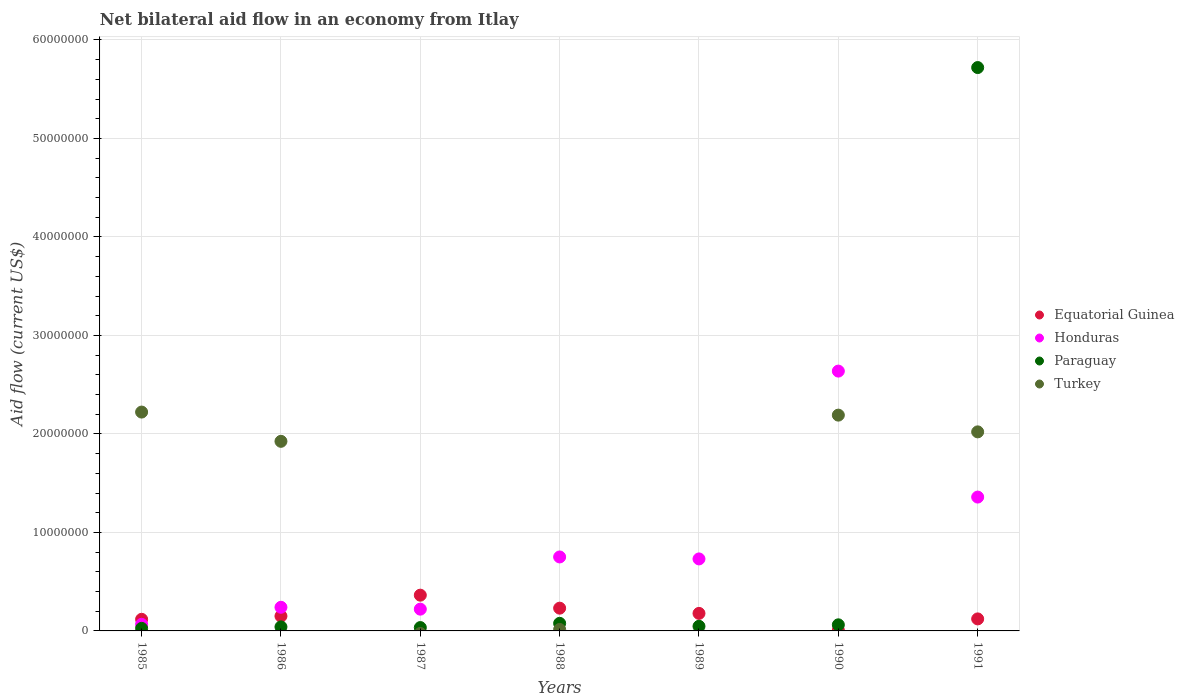How many different coloured dotlines are there?
Provide a succinct answer. 4. Across all years, what is the maximum net bilateral aid flow in Turkey?
Provide a succinct answer. 2.22e+07. Across all years, what is the minimum net bilateral aid flow in Turkey?
Your answer should be very brief. 0. What is the total net bilateral aid flow in Turkey in the graph?
Keep it short and to the point. 8.37e+07. What is the difference between the net bilateral aid flow in Honduras in 1988 and the net bilateral aid flow in Equatorial Guinea in 1989?
Your answer should be very brief. 5.73e+06. What is the average net bilateral aid flow in Honduras per year?
Offer a terse response. 8.58e+06. In the year 1986, what is the difference between the net bilateral aid flow in Turkey and net bilateral aid flow in Paraguay?
Your answer should be very brief. 1.88e+07. What is the ratio of the net bilateral aid flow in Equatorial Guinea in 1986 to that in 1989?
Provide a succinct answer. 0.84. What is the difference between the highest and the lowest net bilateral aid flow in Turkey?
Provide a succinct answer. 2.22e+07. In how many years, is the net bilateral aid flow in Equatorial Guinea greater than the average net bilateral aid flow in Equatorial Guinea taken over all years?
Offer a very short reply. 3. Is it the case that in every year, the sum of the net bilateral aid flow in Paraguay and net bilateral aid flow in Equatorial Guinea  is greater than the sum of net bilateral aid flow in Honduras and net bilateral aid flow in Turkey?
Offer a very short reply. Yes. Is the net bilateral aid flow in Paraguay strictly greater than the net bilateral aid flow in Turkey over the years?
Ensure brevity in your answer.  No. How many years are there in the graph?
Your answer should be very brief. 7. Are the values on the major ticks of Y-axis written in scientific E-notation?
Keep it short and to the point. No. Does the graph contain grids?
Your response must be concise. Yes. Where does the legend appear in the graph?
Make the answer very short. Center right. How are the legend labels stacked?
Offer a very short reply. Vertical. What is the title of the graph?
Your response must be concise. Net bilateral aid flow in an economy from Itlay. What is the Aid flow (current US$) in Equatorial Guinea in 1985?
Your answer should be compact. 1.18e+06. What is the Aid flow (current US$) of Honduras in 1985?
Provide a succinct answer. 6.70e+05. What is the Aid flow (current US$) of Paraguay in 1985?
Your response must be concise. 2.60e+05. What is the Aid flow (current US$) in Turkey in 1985?
Your answer should be very brief. 2.22e+07. What is the Aid flow (current US$) of Equatorial Guinea in 1986?
Give a very brief answer. 1.50e+06. What is the Aid flow (current US$) of Honduras in 1986?
Offer a very short reply. 2.40e+06. What is the Aid flow (current US$) of Turkey in 1986?
Offer a terse response. 1.92e+07. What is the Aid flow (current US$) in Equatorial Guinea in 1987?
Offer a very short reply. 3.63e+06. What is the Aid flow (current US$) of Honduras in 1987?
Keep it short and to the point. 2.21e+06. What is the Aid flow (current US$) of Paraguay in 1987?
Your answer should be compact. 3.40e+05. What is the Aid flow (current US$) of Equatorial Guinea in 1988?
Your answer should be compact. 2.31e+06. What is the Aid flow (current US$) of Honduras in 1988?
Your answer should be very brief. 7.51e+06. What is the Aid flow (current US$) of Paraguay in 1988?
Make the answer very short. 7.70e+05. What is the Aid flow (current US$) in Equatorial Guinea in 1989?
Provide a short and direct response. 1.78e+06. What is the Aid flow (current US$) in Honduras in 1989?
Offer a very short reply. 7.31e+06. What is the Aid flow (current US$) in Paraguay in 1989?
Keep it short and to the point. 4.70e+05. What is the Aid flow (current US$) in Equatorial Guinea in 1990?
Make the answer very short. 7.00e+04. What is the Aid flow (current US$) of Honduras in 1990?
Your answer should be compact. 2.64e+07. What is the Aid flow (current US$) of Paraguay in 1990?
Your answer should be very brief. 6.20e+05. What is the Aid flow (current US$) in Turkey in 1990?
Give a very brief answer. 2.19e+07. What is the Aid flow (current US$) in Equatorial Guinea in 1991?
Your response must be concise. 1.22e+06. What is the Aid flow (current US$) of Honduras in 1991?
Make the answer very short. 1.36e+07. What is the Aid flow (current US$) in Paraguay in 1991?
Offer a terse response. 5.72e+07. What is the Aid flow (current US$) of Turkey in 1991?
Ensure brevity in your answer.  2.02e+07. Across all years, what is the maximum Aid flow (current US$) of Equatorial Guinea?
Give a very brief answer. 3.63e+06. Across all years, what is the maximum Aid flow (current US$) in Honduras?
Keep it short and to the point. 2.64e+07. Across all years, what is the maximum Aid flow (current US$) of Paraguay?
Make the answer very short. 5.72e+07. Across all years, what is the maximum Aid flow (current US$) in Turkey?
Your response must be concise. 2.22e+07. Across all years, what is the minimum Aid flow (current US$) of Equatorial Guinea?
Provide a short and direct response. 7.00e+04. Across all years, what is the minimum Aid flow (current US$) of Honduras?
Keep it short and to the point. 6.70e+05. What is the total Aid flow (current US$) in Equatorial Guinea in the graph?
Your answer should be very brief. 1.17e+07. What is the total Aid flow (current US$) in Honduras in the graph?
Your response must be concise. 6.01e+07. What is the total Aid flow (current US$) of Paraguay in the graph?
Ensure brevity in your answer.  6.01e+07. What is the total Aid flow (current US$) in Turkey in the graph?
Your answer should be compact. 8.37e+07. What is the difference between the Aid flow (current US$) in Equatorial Guinea in 1985 and that in 1986?
Provide a succinct answer. -3.20e+05. What is the difference between the Aid flow (current US$) of Honduras in 1985 and that in 1986?
Your response must be concise. -1.73e+06. What is the difference between the Aid flow (current US$) of Turkey in 1985 and that in 1986?
Offer a very short reply. 2.97e+06. What is the difference between the Aid flow (current US$) in Equatorial Guinea in 1985 and that in 1987?
Your response must be concise. -2.45e+06. What is the difference between the Aid flow (current US$) in Honduras in 1985 and that in 1987?
Your response must be concise. -1.54e+06. What is the difference between the Aid flow (current US$) in Paraguay in 1985 and that in 1987?
Your answer should be compact. -8.00e+04. What is the difference between the Aid flow (current US$) in Equatorial Guinea in 1985 and that in 1988?
Give a very brief answer. -1.13e+06. What is the difference between the Aid flow (current US$) in Honduras in 1985 and that in 1988?
Ensure brevity in your answer.  -6.84e+06. What is the difference between the Aid flow (current US$) in Paraguay in 1985 and that in 1988?
Ensure brevity in your answer.  -5.10e+05. What is the difference between the Aid flow (current US$) in Turkey in 1985 and that in 1988?
Give a very brief answer. 2.21e+07. What is the difference between the Aid flow (current US$) of Equatorial Guinea in 1985 and that in 1989?
Ensure brevity in your answer.  -6.00e+05. What is the difference between the Aid flow (current US$) in Honduras in 1985 and that in 1989?
Provide a short and direct response. -6.64e+06. What is the difference between the Aid flow (current US$) of Paraguay in 1985 and that in 1989?
Provide a short and direct response. -2.10e+05. What is the difference between the Aid flow (current US$) in Equatorial Guinea in 1985 and that in 1990?
Offer a terse response. 1.11e+06. What is the difference between the Aid flow (current US$) of Honduras in 1985 and that in 1990?
Offer a terse response. -2.57e+07. What is the difference between the Aid flow (current US$) in Paraguay in 1985 and that in 1990?
Keep it short and to the point. -3.60e+05. What is the difference between the Aid flow (current US$) of Turkey in 1985 and that in 1990?
Offer a terse response. 3.10e+05. What is the difference between the Aid flow (current US$) of Honduras in 1985 and that in 1991?
Ensure brevity in your answer.  -1.29e+07. What is the difference between the Aid flow (current US$) of Paraguay in 1985 and that in 1991?
Your answer should be compact. -5.69e+07. What is the difference between the Aid flow (current US$) in Turkey in 1985 and that in 1991?
Keep it short and to the point. 2.01e+06. What is the difference between the Aid flow (current US$) in Equatorial Guinea in 1986 and that in 1987?
Your answer should be compact. -2.13e+06. What is the difference between the Aid flow (current US$) of Honduras in 1986 and that in 1987?
Provide a short and direct response. 1.90e+05. What is the difference between the Aid flow (current US$) in Paraguay in 1986 and that in 1987?
Make the answer very short. 7.00e+04. What is the difference between the Aid flow (current US$) of Equatorial Guinea in 1986 and that in 1988?
Your answer should be very brief. -8.10e+05. What is the difference between the Aid flow (current US$) in Honduras in 1986 and that in 1988?
Provide a short and direct response. -5.11e+06. What is the difference between the Aid flow (current US$) in Paraguay in 1986 and that in 1988?
Provide a succinct answer. -3.60e+05. What is the difference between the Aid flow (current US$) in Turkey in 1986 and that in 1988?
Your answer should be compact. 1.91e+07. What is the difference between the Aid flow (current US$) of Equatorial Guinea in 1986 and that in 1989?
Your answer should be very brief. -2.80e+05. What is the difference between the Aid flow (current US$) in Honduras in 1986 and that in 1989?
Ensure brevity in your answer.  -4.91e+06. What is the difference between the Aid flow (current US$) in Equatorial Guinea in 1986 and that in 1990?
Give a very brief answer. 1.43e+06. What is the difference between the Aid flow (current US$) of Honduras in 1986 and that in 1990?
Provide a succinct answer. -2.40e+07. What is the difference between the Aid flow (current US$) in Paraguay in 1986 and that in 1990?
Ensure brevity in your answer.  -2.10e+05. What is the difference between the Aid flow (current US$) of Turkey in 1986 and that in 1990?
Ensure brevity in your answer.  -2.66e+06. What is the difference between the Aid flow (current US$) of Equatorial Guinea in 1986 and that in 1991?
Your answer should be very brief. 2.80e+05. What is the difference between the Aid flow (current US$) in Honduras in 1986 and that in 1991?
Provide a short and direct response. -1.12e+07. What is the difference between the Aid flow (current US$) in Paraguay in 1986 and that in 1991?
Provide a short and direct response. -5.68e+07. What is the difference between the Aid flow (current US$) in Turkey in 1986 and that in 1991?
Your answer should be compact. -9.60e+05. What is the difference between the Aid flow (current US$) in Equatorial Guinea in 1987 and that in 1988?
Keep it short and to the point. 1.32e+06. What is the difference between the Aid flow (current US$) in Honduras in 1987 and that in 1988?
Keep it short and to the point. -5.30e+06. What is the difference between the Aid flow (current US$) in Paraguay in 1987 and that in 1988?
Make the answer very short. -4.30e+05. What is the difference between the Aid flow (current US$) in Equatorial Guinea in 1987 and that in 1989?
Your response must be concise. 1.85e+06. What is the difference between the Aid flow (current US$) in Honduras in 1987 and that in 1989?
Make the answer very short. -5.10e+06. What is the difference between the Aid flow (current US$) in Paraguay in 1987 and that in 1989?
Provide a short and direct response. -1.30e+05. What is the difference between the Aid flow (current US$) in Equatorial Guinea in 1987 and that in 1990?
Keep it short and to the point. 3.56e+06. What is the difference between the Aid flow (current US$) in Honduras in 1987 and that in 1990?
Offer a terse response. -2.42e+07. What is the difference between the Aid flow (current US$) of Paraguay in 1987 and that in 1990?
Provide a succinct answer. -2.80e+05. What is the difference between the Aid flow (current US$) of Equatorial Guinea in 1987 and that in 1991?
Give a very brief answer. 2.41e+06. What is the difference between the Aid flow (current US$) of Honduras in 1987 and that in 1991?
Provide a succinct answer. -1.14e+07. What is the difference between the Aid flow (current US$) of Paraguay in 1987 and that in 1991?
Ensure brevity in your answer.  -5.69e+07. What is the difference between the Aid flow (current US$) in Equatorial Guinea in 1988 and that in 1989?
Your response must be concise. 5.30e+05. What is the difference between the Aid flow (current US$) in Paraguay in 1988 and that in 1989?
Your response must be concise. 3.00e+05. What is the difference between the Aid flow (current US$) in Equatorial Guinea in 1988 and that in 1990?
Provide a short and direct response. 2.24e+06. What is the difference between the Aid flow (current US$) of Honduras in 1988 and that in 1990?
Provide a short and direct response. -1.89e+07. What is the difference between the Aid flow (current US$) of Paraguay in 1988 and that in 1990?
Your answer should be compact. 1.50e+05. What is the difference between the Aid flow (current US$) in Turkey in 1988 and that in 1990?
Your answer should be compact. -2.18e+07. What is the difference between the Aid flow (current US$) of Equatorial Guinea in 1988 and that in 1991?
Provide a succinct answer. 1.09e+06. What is the difference between the Aid flow (current US$) of Honduras in 1988 and that in 1991?
Your response must be concise. -6.08e+06. What is the difference between the Aid flow (current US$) in Paraguay in 1988 and that in 1991?
Your answer should be compact. -5.64e+07. What is the difference between the Aid flow (current US$) in Turkey in 1988 and that in 1991?
Your answer should be compact. -2.01e+07. What is the difference between the Aid flow (current US$) in Equatorial Guinea in 1989 and that in 1990?
Your response must be concise. 1.71e+06. What is the difference between the Aid flow (current US$) of Honduras in 1989 and that in 1990?
Keep it short and to the point. -1.91e+07. What is the difference between the Aid flow (current US$) in Equatorial Guinea in 1989 and that in 1991?
Offer a terse response. 5.60e+05. What is the difference between the Aid flow (current US$) of Honduras in 1989 and that in 1991?
Make the answer very short. -6.28e+06. What is the difference between the Aid flow (current US$) in Paraguay in 1989 and that in 1991?
Your response must be concise. -5.67e+07. What is the difference between the Aid flow (current US$) in Equatorial Guinea in 1990 and that in 1991?
Ensure brevity in your answer.  -1.15e+06. What is the difference between the Aid flow (current US$) of Honduras in 1990 and that in 1991?
Offer a very short reply. 1.28e+07. What is the difference between the Aid flow (current US$) in Paraguay in 1990 and that in 1991?
Provide a short and direct response. -5.66e+07. What is the difference between the Aid flow (current US$) of Turkey in 1990 and that in 1991?
Provide a succinct answer. 1.70e+06. What is the difference between the Aid flow (current US$) in Equatorial Guinea in 1985 and the Aid flow (current US$) in Honduras in 1986?
Ensure brevity in your answer.  -1.22e+06. What is the difference between the Aid flow (current US$) of Equatorial Guinea in 1985 and the Aid flow (current US$) of Paraguay in 1986?
Make the answer very short. 7.70e+05. What is the difference between the Aid flow (current US$) in Equatorial Guinea in 1985 and the Aid flow (current US$) in Turkey in 1986?
Give a very brief answer. -1.81e+07. What is the difference between the Aid flow (current US$) in Honduras in 1985 and the Aid flow (current US$) in Paraguay in 1986?
Provide a short and direct response. 2.60e+05. What is the difference between the Aid flow (current US$) of Honduras in 1985 and the Aid flow (current US$) of Turkey in 1986?
Give a very brief answer. -1.86e+07. What is the difference between the Aid flow (current US$) in Paraguay in 1985 and the Aid flow (current US$) in Turkey in 1986?
Make the answer very short. -1.90e+07. What is the difference between the Aid flow (current US$) of Equatorial Guinea in 1985 and the Aid flow (current US$) of Honduras in 1987?
Provide a succinct answer. -1.03e+06. What is the difference between the Aid flow (current US$) in Equatorial Guinea in 1985 and the Aid flow (current US$) in Paraguay in 1987?
Ensure brevity in your answer.  8.40e+05. What is the difference between the Aid flow (current US$) in Honduras in 1985 and the Aid flow (current US$) in Paraguay in 1987?
Give a very brief answer. 3.30e+05. What is the difference between the Aid flow (current US$) of Equatorial Guinea in 1985 and the Aid flow (current US$) of Honduras in 1988?
Give a very brief answer. -6.33e+06. What is the difference between the Aid flow (current US$) of Equatorial Guinea in 1985 and the Aid flow (current US$) of Turkey in 1988?
Your response must be concise. 1.03e+06. What is the difference between the Aid flow (current US$) of Honduras in 1985 and the Aid flow (current US$) of Paraguay in 1988?
Offer a very short reply. -1.00e+05. What is the difference between the Aid flow (current US$) in Honduras in 1985 and the Aid flow (current US$) in Turkey in 1988?
Your answer should be very brief. 5.20e+05. What is the difference between the Aid flow (current US$) of Paraguay in 1985 and the Aid flow (current US$) of Turkey in 1988?
Your answer should be compact. 1.10e+05. What is the difference between the Aid flow (current US$) of Equatorial Guinea in 1985 and the Aid flow (current US$) of Honduras in 1989?
Keep it short and to the point. -6.13e+06. What is the difference between the Aid flow (current US$) of Equatorial Guinea in 1985 and the Aid flow (current US$) of Paraguay in 1989?
Give a very brief answer. 7.10e+05. What is the difference between the Aid flow (current US$) of Honduras in 1985 and the Aid flow (current US$) of Paraguay in 1989?
Keep it short and to the point. 2.00e+05. What is the difference between the Aid flow (current US$) in Equatorial Guinea in 1985 and the Aid flow (current US$) in Honduras in 1990?
Your answer should be very brief. -2.52e+07. What is the difference between the Aid flow (current US$) in Equatorial Guinea in 1985 and the Aid flow (current US$) in Paraguay in 1990?
Your answer should be very brief. 5.60e+05. What is the difference between the Aid flow (current US$) in Equatorial Guinea in 1985 and the Aid flow (current US$) in Turkey in 1990?
Your answer should be compact. -2.07e+07. What is the difference between the Aid flow (current US$) of Honduras in 1985 and the Aid flow (current US$) of Turkey in 1990?
Offer a terse response. -2.12e+07. What is the difference between the Aid flow (current US$) in Paraguay in 1985 and the Aid flow (current US$) in Turkey in 1990?
Make the answer very short. -2.16e+07. What is the difference between the Aid flow (current US$) in Equatorial Guinea in 1985 and the Aid flow (current US$) in Honduras in 1991?
Make the answer very short. -1.24e+07. What is the difference between the Aid flow (current US$) of Equatorial Guinea in 1985 and the Aid flow (current US$) of Paraguay in 1991?
Your answer should be very brief. -5.60e+07. What is the difference between the Aid flow (current US$) in Equatorial Guinea in 1985 and the Aid flow (current US$) in Turkey in 1991?
Ensure brevity in your answer.  -1.90e+07. What is the difference between the Aid flow (current US$) in Honduras in 1985 and the Aid flow (current US$) in Paraguay in 1991?
Give a very brief answer. -5.65e+07. What is the difference between the Aid flow (current US$) in Honduras in 1985 and the Aid flow (current US$) in Turkey in 1991?
Your answer should be very brief. -1.95e+07. What is the difference between the Aid flow (current US$) of Paraguay in 1985 and the Aid flow (current US$) of Turkey in 1991?
Offer a terse response. -2.00e+07. What is the difference between the Aid flow (current US$) of Equatorial Guinea in 1986 and the Aid flow (current US$) of Honduras in 1987?
Ensure brevity in your answer.  -7.10e+05. What is the difference between the Aid flow (current US$) of Equatorial Guinea in 1986 and the Aid flow (current US$) of Paraguay in 1987?
Make the answer very short. 1.16e+06. What is the difference between the Aid flow (current US$) in Honduras in 1986 and the Aid flow (current US$) in Paraguay in 1987?
Offer a very short reply. 2.06e+06. What is the difference between the Aid flow (current US$) of Equatorial Guinea in 1986 and the Aid flow (current US$) of Honduras in 1988?
Your response must be concise. -6.01e+06. What is the difference between the Aid flow (current US$) of Equatorial Guinea in 1986 and the Aid flow (current US$) of Paraguay in 1988?
Give a very brief answer. 7.30e+05. What is the difference between the Aid flow (current US$) of Equatorial Guinea in 1986 and the Aid flow (current US$) of Turkey in 1988?
Give a very brief answer. 1.35e+06. What is the difference between the Aid flow (current US$) of Honduras in 1986 and the Aid flow (current US$) of Paraguay in 1988?
Ensure brevity in your answer.  1.63e+06. What is the difference between the Aid flow (current US$) of Honduras in 1986 and the Aid flow (current US$) of Turkey in 1988?
Give a very brief answer. 2.25e+06. What is the difference between the Aid flow (current US$) in Paraguay in 1986 and the Aid flow (current US$) in Turkey in 1988?
Provide a short and direct response. 2.60e+05. What is the difference between the Aid flow (current US$) of Equatorial Guinea in 1986 and the Aid flow (current US$) of Honduras in 1989?
Provide a succinct answer. -5.81e+06. What is the difference between the Aid flow (current US$) of Equatorial Guinea in 1986 and the Aid flow (current US$) of Paraguay in 1989?
Your answer should be compact. 1.03e+06. What is the difference between the Aid flow (current US$) in Honduras in 1986 and the Aid flow (current US$) in Paraguay in 1989?
Your response must be concise. 1.93e+06. What is the difference between the Aid flow (current US$) in Equatorial Guinea in 1986 and the Aid flow (current US$) in Honduras in 1990?
Your response must be concise. -2.49e+07. What is the difference between the Aid flow (current US$) of Equatorial Guinea in 1986 and the Aid flow (current US$) of Paraguay in 1990?
Keep it short and to the point. 8.80e+05. What is the difference between the Aid flow (current US$) of Equatorial Guinea in 1986 and the Aid flow (current US$) of Turkey in 1990?
Offer a terse response. -2.04e+07. What is the difference between the Aid flow (current US$) of Honduras in 1986 and the Aid flow (current US$) of Paraguay in 1990?
Provide a short and direct response. 1.78e+06. What is the difference between the Aid flow (current US$) of Honduras in 1986 and the Aid flow (current US$) of Turkey in 1990?
Offer a very short reply. -1.95e+07. What is the difference between the Aid flow (current US$) of Paraguay in 1986 and the Aid flow (current US$) of Turkey in 1990?
Offer a terse response. -2.15e+07. What is the difference between the Aid flow (current US$) in Equatorial Guinea in 1986 and the Aid flow (current US$) in Honduras in 1991?
Your response must be concise. -1.21e+07. What is the difference between the Aid flow (current US$) in Equatorial Guinea in 1986 and the Aid flow (current US$) in Paraguay in 1991?
Your answer should be compact. -5.57e+07. What is the difference between the Aid flow (current US$) in Equatorial Guinea in 1986 and the Aid flow (current US$) in Turkey in 1991?
Provide a succinct answer. -1.87e+07. What is the difference between the Aid flow (current US$) in Honduras in 1986 and the Aid flow (current US$) in Paraguay in 1991?
Offer a very short reply. -5.48e+07. What is the difference between the Aid flow (current US$) of Honduras in 1986 and the Aid flow (current US$) of Turkey in 1991?
Keep it short and to the point. -1.78e+07. What is the difference between the Aid flow (current US$) in Paraguay in 1986 and the Aid flow (current US$) in Turkey in 1991?
Your answer should be very brief. -1.98e+07. What is the difference between the Aid flow (current US$) in Equatorial Guinea in 1987 and the Aid flow (current US$) in Honduras in 1988?
Your response must be concise. -3.88e+06. What is the difference between the Aid flow (current US$) of Equatorial Guinea in 1987 and the Aid flow (current US$) of Paraguay in 1988?
Your response must be concise. 2.86e+06. What is the difference between the Aid flow (current US$) of Equatorial Guinea in 1987 and the Aid flow (current US$) of Turkey in 1988?
Give a very brief answer. 3.48e+06. What is the difference between the Aid flow (current US$) in Honduras in 1987 and the Aid flow (current US$) in Paraguay in 1988?
Offer a terse response. 1.44e+06. What is the difference between the Aid flow (current US$) of Honduras in 1987 and the Aid flow (current US$) of Turkey in 1988?
Give a very brief answer. 2.06e+06. What is the difference between the Aid flow (current US$) of Paraguay in 1987 and the Aid flow (current US$) of Turkey in 1988?
Keep it short and to the point. 1.90e+05. What is the difference between the Aid flow (current US$) of Equatorial Guinea in 1987 and the Aid flow (current US$) of Honduras in 1989?
Provide a short and direct response. -3.68e+06. What is the difference between the Aid flow (current US$) in Equatorial Guinea in 1987 and the Aid flow (current US$) in Paraguay in 1989?
Make the answer very short. 3.16e+06. What is the difference between the Aid flow (current US$) in Honduras in 1987 and the Aid flow (current US$) in Paraguay in 1989?
Provide a succinct answer. 1.74e+06. What is the difference between the Aid flow (current US$) of Equatorial Guinea in 1987 and the Aid flow (current US$) of Honduras in 1990?
Provide a short and direct response. -2.28e+07. What is the difference between the Aid flow (current US$) in Equatorial Guinea in 1987 and the Aid flow (current US$) in Paraguay in 1990?
Give a very brief answer. 3.01e+06. What is the difference between the Aid flow (current US$) in Equatorial Guinea in 1987 and the Aid flow (current US$) in Turkey in 1990?
Give a very brief answer. -1.83e+07. What is the difference between the Aid flow (current US$) in Honduras in 1987 and the Aid flow (current US$) in Paraguay in 1990?
Provide a succinct answer. 1.59e+06. What is the difference between the Aid flow (current US$) of Honduras in 1987 and the Aid flow (current US$) of Turkey in 1990?
Your answer should be compact. -1.97e+07. What is the difference between the Aid flow (current US$) of Paraguay in 1987 and the Aid flow (current US$) of Turkey in 1990?
Your response must be concise. -2.16e+07. What is the difference between the Aid flow (current US$) in Equatorial Guinea in 1987 and the Aid flow (current US$) in Honduras in 1991?
Give a very brief answer. -9.96e+06. What is the difference between the Aid flow (current US$) in Equatorial Guinea in 1987 and the Aid flow (current US$) in Paraguay in 1991?
Your answer should be compact. -5.36e+07. What is the difference between the Aid flow (current US$) of Equatorial Guinea in 1987 and the Aid flow (current US$) of Turkey in 1991?
Your response must be concise. -1.66e+07. What is the difference between the Aid flow (current US$) in Honduras in 1987 and the Aid flow (current US$) in Paraguay in 1991?
Make the answer very short. -5.50e+07. What is the difference between the Aid flow (current US$) of Honduras in 1987 and the Aid flow (current US$) of Turkey in 1991?
Keep it short and to the point. -1.80e+07. What is the difference between the Aid flow (current US$) in Paraguay in 1987 and the Aid flow (current US$) in Turkey in 1991?
Ensure brevity in your answer.  -1.99e+07. What is the difference between the Aid flow (current US$) of Equatorial Guinea in 1988 and the Aid flow (current US$) of Honduras in 1989?
Your answer should be very brief. -5.00e+06. What is the difference between the Aid flow (current US$) of Equatorial Guinea in 1988 and the Aid flow (current US$) of Paraguay in 1989?
Offer a very short reply. 1.84e+06. What is the difference between the Aid flow (current US$) of Honduras in 1988 and the Aid flow (current US$) of Paraguay in 1989?
Offer a very short reply. 7.04e+06. What is the difference between the Aid flow (current US$) in Equatorial Guinea in 1988 and the Aid flow (current US$) in Honduras in 1990?
Make the answer very short. -2.41e+07. What is the difference between the Aid flow (current US$) in Equatorial Guinea in 1988 and the Aid flow (current US$) in Paraguay in 1990?
Keep it short and to the point. 1.69e+06. What is the difference between the Aid flow (current US$) in Equatorial Guinea in 1988 and the Aid flow (current US$) in Turkey in 1990?
Provide a succinct answer. -1.96e+07. What is the difference between the Aid flow (current US$) in Honduras in 1988 and the Aid flow (current US$) in Paraguay in 1990?
Your answer should be very brief. 6.89e+06. What is the difference between the Aid flow (current US$) in Honduras in 1988 and the Aid flow (current US$) in Turkey in 1990?
Give a very brief answer. -1.44e+07. What is the difference between the Aid flow (current US$) in Paraguay in 1988 and the Aid flow (current US$) in Turkey in 1990?
Give a very brief answer. -2.11e+07. What is the difference between the Aid flow (current US$) of Equatorial Guinea in 1988 and the Aid flow (current US$) of Honduras in 1991?
Give a very brief answer. -1.13e+07. What is the difference between the Aid flow (current US$) in Equatorial Guinea in 1988 and the Aid flow (current US$) in Paraguay in 1991?
Keep it short and to the point. -5.49e+07. What is the difference between the Aid flow (current US$) in Equatorial Guinea in 1988 and the Aid flow (current US$) in Turkey in 1991?
Make the answer very short. -1.79e+07. What is the difference between the Aid flow (current US$) of Honduras in 1988 and the Aid flow (current US$) of Paraguay in 1991?
Keep it short and to the point. -4.97e+07. What is the difference between the Aid flow (current US$) of Honduras in 1988 and the Aid flow (current US$) of Turkey in 1991?
Your response must be concise. -1.27e+07. What is the difference between the Aid flow (current US$) of Paraguay in 1988 and the Aid flow (current US$) of Turkey in 1991?
Provide a succinct answer. -1.94e+07. What is the difference between the Aid flow (current US$) of Equatorial Guinea in 1989 and the Aid flow (current US$) of Honduras in 1990?
Give a very brief answer. -2.46e+07. What is the difference between the Aid flow (current US$) of Equatorial Guinea in 1989 and the Aid flow (current US$) of Paraguay in 1990?
Offer a very short reply. 1.16e+06. What is the difference between the Aid flow (current US$) in Equatorial Guinea in 1989 and the Aid flow (current US$) in Turkey in 1990?
Provide a succinct answer. -2.01e+07. What is the difference between the Aid flow (current US$) of Honduras in 1989 and the Aid flow (current US$) of Paraguay in 1990?
Provide a short and direct response. 6.69e+06. What is the difference between the Aid flow (current US$) of Honduras in 1989 and the Aid flow (current US$) of Turkey in 1990?
Provide a short and direct response. -1.46e+07. What is the difference between the Aid flow (current US$) in Paraguay in 1989 and the Aid flow (current US$) in Turkey in 1990?
Your response must be concise. -2.14e+07. What is the difference between the Aid flow (current US$) in Equatorial Guinea in 1989 and the Aid flow (current US$) in Honduras in 1991?
Your answer should be compact. -1.18e+07. What is the difference between the Aid flow (current US$) of Equatorial Guinea in 1989 and the Aid flow (current US$) of Paraguay in 1991?
Your answer should be compact. -5.54e+07. What is the difference between the Aid flow (current US$) of Equatorial Guinea in 1989 and the Aid flow (current US$) of Turkey in 1991?
Provide a short and direct response. -1.84e+07. What is the difference between the Aid flow (current US$) of Honduras in 1989 and the Aid flow (current US$) of Paraguay in 1991?
Offer a very short reply. -4.99e+07. What is the difference between the Aid flow (current US$) of Honduras in 1989 and the Aid flow (current US$) of Turkey in 1991?
Ensure brevity in your answer.  -1.29e+07. What is the difference between the Aid flow (current US$) of Paraguay in 1989 and the Aid flow (current US$) of Turkey in 1991?
Your answer should be compact. -1.97e+07. What is the difference between the Aid flow (current US$) in Equatorial Guinea in 1990 and the Aid flow (current US$) in Honduras in 1991?
Ensure brevity in your answer.  -1.35e+07. What is the difference between the Aid flow (current US$) in Equatorial Guinea in 1990 and the Aid flow (current US$) in Paraguay in 1991?
Your response must be concise. -5.71e+07. What is the difference between the Aid flow (current US$) of Equatorial Guinea in 1990 and the Aid flow (current US$) of Turkey in 1991?
Your response must be concise. -2.01e+07. What is the difference between the Aid flow (current US$) of Honduras in 1990 and the Aid flow (current US$) of Paraguay in 1991?
Your answer should be compact. -3.08e+07. What is the difference between the Aid flow (current US$) in Honduras in 1990 and the Aid flow (current US$) in Turkey in 1991?
Give a very brief answer. 6.17e+06. What is the difference between the Aid flow (current US$) in Paraguay in 1990 and the Aid flow (current US$) in Turkey in 1991?
Make the answer very short. -1.96e+07. What is the average Aid flow (current US$) in Equatorial Guinea per year?
Your answer should be very brief. 1.67e+06. What is the average Aid flow (current US$) in Honduras per year?
Make the answer very short. 8.58e+06. What is the average Aid flow (current US$) in Paraguay per year?
Keep it short and to the point. 8.58e+06. What is the average Aid flow (current US$) of Turkey per year?
Make the answer very short. 1.20e+07. In the year 1985, what is the difference between the Aid flow (current US$) of Equatorial Guinea and Aid flow (current US$) of Honduras?
Provide a succinct answer. 5.10e+05. In the year 1985, what is the difference between the Aid flow (current US$) in Equatorial Guinea and Aid flow (current US$) in Paraguay?
Give a very brief answer. 9.20e+05. In the year 1985, what is the difference between the Aid flow (current US$) of Equatorial Guinea and Aid flow (current US$) of Turkey?
Your response must be concise. -2.10e+07. In the year 1985, what is the difference between the Aid flow (current US$) of Honduras and Aid flow (current US$) of Turkey?
Provide a succinct answer. -2.16e+07. In the year 1985, what is the difference between the Aid flow (current US$) in Paraguay and Aid flow (current US$) in Turkey?
Ensure brevity in your answer.  -2.20e+07. In the year 1986, what is the difference between the Aid flow (current US$) of Equatorial Guinea and Aid flow (current US$) of Honduras?
Make the answer very short. -9.00e+05. In the year 1986, what is the difference between the Aid flow (current US$) of Equatorial Guinea and Aid flow (current US$) of Paraguay?
Your answer should be compact. 1.09e+06. In the year 1986, what is the difference between the Aid flow (current US$) in Equatorial Guinea and Aid flow (current US$) in Turkey?
Ensure brevity in your answer.  -1.78e+07. In the year 1986, what is the difference between the Aid flow (current US$) in Honduras and Aid flow (current US$) in Paraguay?
Make the answer very short. 1.99e+06. In the year 1986, what is the difference between the Aid flow (current US$) in Honduras and Aid flow (current US$) in Turkey?
Provide a short and direct response. -1.68e+07. In the year 1986, what is the difference between the Aid flow (current US$) in Paraguay and Aid flow (current US$) in Turkey?
Make the answer very short. -1.88e+07. In the year 1987, what is the difference between the Aid flow (current US$) of Equatorial Guinea and Aid flow (current US$) of Honduras?
Make the answer very short. 1.42e+06. In the year 1987, what is the difference between the Aid flow (current US$) in Equatorial Guinea and Aid flow (current US$) in Paraguay?
Your response must be concise. 3.29e+06. In the year 1987, what is the difference between the Aid flow (current US$) of Honduras and Aid flow (current US$) of Paraguay?
Your answer should be very brief. 1.87e+06. In the year 1988, what is the difference between the Aid flow (current US$) in Equatorial Guinea and Aid flow (current US$) in Honduras?
Your answer should be compact. -5.20e+06. In the year 1988, what is the difference between the Aid flow (current US$) of Equatorial Guinea and Aid flow (current US$) of Paraguay?
Make the answer very short. 1.54e+06. In the year 1988, what is the difference between the Aid flow (current US$) of Equatorial Guinea and Aid flow (current US$) of Turkey?
Keep it short and to the point. 2.16e+06. In the year 1988, what is the difference between the Aid flow (current US$) of Honduras and Aid flow (current US$) of Paraguay?
Provide a short and direct response. 6.74e+06. In the year 1988, what is the difference between the Aid flow (current US$) in Honduras and Aid flow (current US$) in Turkey?
Your answer should be compact. 7.36e+06. In the year 1988, what is the difference between the Aid flow (current US$) of Paraguay and Aid flow (current US$) of Turkey?
Make the answer very short. 6.20e+05. In the year 1989, what is the difference between the Aid flow (current US$) of Equatorial Guinea and Aid flow (current US$) of Honduras?
Your answer should be compact. -5.53e+06. In the year 1989, what is the difference between the Aid flow (current US$) in Equatorial Guinea and Aid flow (current US$) in Paraguay?
Your answer should be very brief. 1.31e+06. In the year 1989, what is the difference between the Aid flow (current US$) in Honduras and Aid flow (current US$) in Paraguay?
Provide a succinct answer. 6.84e+06. In the year 1990, what is the difference between the Aid flow (current US$) of Equatorial Guinea and Aid flow (current US$) of Honduras?
Provide a short and direct response. -2.63e+07. In the year 1990, what is the difference between the Aid flow (current US$) of Equatorial Guinea and Aid flow (current US$) of Paraguay?
Your answer should be very brief. -5.50e+05. In the year 1990, what is the difference between the Aid flow (current US$) of Equatorial Guinea and Aid flow (current US$) of Turkey?
Ensure brevity in your answer.  -2.18e+07. In the year 1990, what is the difference between the Aid flow (current US$) in Honduras and Aid flow (current US$) in Paraguay?
Provide a short and direct response. 2.58e+07. In the year 1990, what is the difference between the Aid flow (current US$) of Honduras and Aid flow (current US$) of Turkey?
Ensure brevity in your answer.  4.47e+06. In the year 1990, what is the difference between the Aid flow (current US$) in Paraguay and Aid flow (current US$) in Turkey?
Give a very brief answer. -2.13e+07. In the year 1991, what is the difference between the Aid flow (current US$) in Equatorial Guinea and Aid flow (current US$) in Honduras?
Make the answer very short. -1.24e+07. In the year 1991, what is the difference between the Aid flow (current US$) of Equatorial Guinea and Aid flow (current US$) of Paraguay?
Your response must be concise. -5.60e+07. In the year 1991, what is the difference between the Aid flow (current US$) in Equatorial Guinea and Aid flow (current US$) in Turkey?
Ensure brevity in your answer.  -1.90e+07. In the year 1991, what is the difference between the Aid flow (current US$) of Honduras and Aid flow (current US$) of Paraguay?
Ensure brevity in your answer.  -4.36e+07. In the year 1991, what is the difference between the Aid flow (current US$) of Honduras and Aid flow (current US$) of Turkey?
Provide a succinct answer. -6.62e+06. In the year 1991, what is the difference between the Aid flow (current US$) in Paraguay and Aid flow (current US$) in Turkey?
Keep it short and to the point. 3.70e+07. What is the ratio of the Aid flow (current US$) in Equatorial Guinea in 1985 to that in 1986?
Give a very brief answer. 0.79. What is the ratio of the Aid flow (current US$) of Honduras in 1985 to that in 1986?
Ensure brevity in your answer.  0.28. What is the ratio of the Aid flow (current US$) of Paraguay in 1985 to that in 1986?
Your answer should be very brief. 0.63. What is the ratio of the Aid flow (current US$) in Turkey in 1985 to that in 1986?
Give a very brief answer. 1.15. What is the ratio of the Aid flow (current US$) in Equatorial Guinea in 1985 to that in 1987?
Your answer should be compact. 0.33. What is the ratio of the Aid flow (current US$) of Honduras in 1985 to that in 1987?
Your response must be concise. 0.3. What is the ratio of the Aid flow (current US$) of Paraguay in 1985 to that in 1987?
Provide a short and direct response. 0.76. What is the ratio of the Aid flow (current US$) in Equatorial Guinea in 1985 to that in 1988?
Offer a very short reply. 0.51. What is the ratio of the Aid flow (current US$) in Honduras in 1985 to that in 1988?
Your answer should be compact. 0.09. What is the ratio of the Aid flow (current US$) in Paraguay in 1985 to that in 1988?
Offer a very short reply. 0.34. What is the ratio of the Aid flow (current US$) of Turkey in 1985 to that in 1988?
Your answer should be compact. 148.13. What is the ratio of the Aid flow (current US$) of Equatorial Guinea in 1985 to that in 1989?
Your answer should be very brief. 0.66. What is the ratio of the Aid flow (current US$) in Honduras in 1985 to that in 1989?
Offer a terse response. 0.09. What is the ratio of the Aid flow (current US$) in Paraguay in 1985 to that in 1989?
Provide a succinct answer. 0.55. What is the ratio of the Aid flow (current US$) of Equatorial Guinea in 1985 to that in 1990?
Your answer should be very brief. 16.86. What is the ratio of the Aid flow (current US$) in Honduras in 1985 to that in 1990?
Your answer should be very brief. 0.03. What is the ratio of the Aid flow (current US$) in Paraguay in 1985 to that in 1990?
Your answer should be compact. 0.42. What is the ratio of the Aid flow (current US$) in Turkey in 1985 to that in 1990?
Give a very brief answer. 1.01. What is the ratio of the Aid flow (current US$) in Equatorial Guinea in 1985 to that in 1991?
Provide a succinct answer. 0.97. What is the ratio of the Aid flow (current US$) of Honduras in 1985 to that in 1991?
Offer a terse response. 0.05. What is the ratio of the Aid flow (current US$) of Paraguay in 1985 to that in 1991?
Make the answer very short. 0. What is the ratio of the Aid flow (current US$) of Turkey in 1985 to that in 1991?
Make the answer very short. 1.1. What is the ratio of the Aid flow (current US$) of Equatorial Guinea in 1986 to that in 1987?
Keep it short and to the point. 0.41. What is the ratio of the Aid flow (current US$) of Honduras in 1986 to that in 1987?
Your response must be concise. 1.09. What is the ratio of the Aid flow (current US$) in Paraguay in 1986 to that in 1987?
Give a very brief answer. 1.21. What is the ratio of the Aid flow (current US$) of Equatorial Guinea in 1986 to that in 1988?
Keep it short and to the point. 0.65. What is the ratio of the Aid flow (current US$) of Honduras in 1986 to that in 1988?
Your answer should be very brief. 0.32. What is the ratio of the Aid flow (current US$) in Paraguay in 1986 to that in 1988?
Offer a very short reply. 0.53. What is the ratio of the Aid flow (current US$) of Turkey in 1986 to that in 1988?
Keep it short and to the point. 128.33. What is the ratio of the Aid flow (current US$) in Equatorial Guinea in 1986 to that in 1989?
Your answer should be compact. 0.84. What is the ratio of the Aid flow (current US$) in Honduras in 1986 to that in 1989?
Give a very brief answer. 0.33. What is the ratio of the Aid flow (current US$) in Paraguay in 1986 to that in 1989?
Offer a very short reply. 0.87. What is the ratio of the Aid flow (current US$) of Equatorial Guinea in 1986 to that in 1990?
Offer a terse response. 21.43. What is the ratio of the Aid flow (current US$) in Honduras in 1986 to that in 1990?
Provide a succinct answer. 0.09. What is the ratio of the Aid flow (current US$) in Paraguay in 1986 to that in 1990?
Your answer should be compact. 0.66. What is the ratio of the Aid flow (current US$) in Turkey in 1986 to that in 1990?
Keep it short and to the point. 0.88. What is the ratio of the Aid flow (current US$) in Equatorial Guinea in 1986 to that in 1991?
Your answer should be compact. 1.23. What is the ratio of the Aid flow (current US$) in Honduras in 1986 to that in 1991?
Ensure brevity in your answer.  0.18. What is the ratio of the Aid flow (current US$) in Paraguay in 1986 to that in 1991?
Your response must be concise. 0.01. What is the ratio of the Aid flow (current US$) in Turkey in 1986 to that in 1991?
Your answer should be compact. 0.95. What is the ratio of the Aid flow (current US$) of Equatorial Guinea in 1987 to that in 1988?
Keep it short and to the point. 1.57. What is the ratio of the Aid flow (current US$) of Honduras in 1987 to that in 1988?
Make the answer very short. 0.29. What is the ratio of the Aid flow (current US$) of Paraguay in 1987 to that in 1988?
Your answer should be compact. 0.44. What is the ratio of the Aid flow (current US$) in Equatorial Guinea in 1987 to that in 1989?
Keep it short and to the point. 2.04. What is the ratio of the Aid flow (current US$) of Honduras in 1987 to that in 1989?
Your answer should be compact. 0.3. What is the ratio of the Aid flow (current US$) of Paraguay in 1987 to that in 1989?
Offer a very short reply. 0.72. What is the ratio of the Aid flow (current US$) of Equatorial Guinea in 1987 to that in 1990?
Give a very brief answer. 51.86. What is the ratio of the Aid flow (current US$) in Honduras in 1987 to that in 1990?
Provide a short and direct response. 0.08. What is the ratio of the Aid flow (current US$) of Paraguay in 1987 to that in 1990?
Give a very brief answer. 0.55. What is the ratio of the Aid flow (current US$) in Equatorial Guinea in 1987 to that in 1991?
Your answer should be compact. 2.98. What is the ratio of the Aid flow (current US$) in Honduras in 1987 to that in 1991?
Provide a succinct answer. 0.16. What is the ratio of the Aid flow (current US$) of Paraguay in 1987 to that in 1991?
Give a very brief answer. 0.01. What is the ratio of the Aid flow (current US$) in Equatorial Guinea in 1988 to that in 1989?
Provide a succinct answer. 1.3. What is the ratio of the Aid flow (current US$) of Honduras in 1988 to that in 1989?
Keep it short and to the point. 1.03. What is the ratio of the Aid flow (current US$) in Paraguay in 1988 to that in 1989?
Ensure brevity in your answer.  1.64. What is the ratio of the Aid flow (current US$) in Equatorial Guinea in 1988 to that in 1990?
Ensure brevity in your answer.  33. What is the ratio of the Aid flow (current US$) of Honduras in 1988 to that in 1990?
Offer a terse response. 0.28. What is the ratio of the Aid flow (current US$) in Paraguay in 1988 to that in 1990?
Offer a very short reply. 1.24. What is the ratio of the Aid flow (current US$) in Turkey in 1988 to that in 1990?
Make the answer very short. 0.01. What is the ratio of the Aid flow (current US$) of Equatorial Guinea in 1988 to that in 1991?
Provide a succinct answer. 1.89. What is the ratio of the Aid flow (current US$) in Honduras in 1988 to that in 1991?
Ensure brevity in your answer.  0.55. What is the ratio of the Aid flow (current US$) in Paraguay in 1988 to that in 1991?
Ensure brevity in your answer.  0.01. What is the ratio of the Aid flow (current US$) of Turkey in 1988 to that in 1991?
Your response must be concise. 0.01. What is the ratio of the Aid flow (current US$) in Equatorial Guinea in 1989 to that in 1990?
Make the answer very short. 25.43. What is the ratio of the Aid flow (current US$) of Honduras in 1989 to that in 1990?
Provide a succinct answer. 0.28. What is the ratio of the Aid flow (current US$) in Paraguay in 1989 to that in 1990?
Your answer should be compact. 0.76. What is the ratio of the Aid flow (current US$) of Equatorial Guinea in 1989 to that in 1991?
Your answer should be very brief. 1.46. What is the ratio of the Aid flow (current US$) in Honduras in 1989 to that in 1991?
Offer a terse response. 0.54. What is the ratio of the Aid flow (current US$) of Paraguay in 1989 to that in 1991?
Your response must be concise. 0.01. What is the ratio of the Aid flow (current US$) in Equatorial Guinea in 1990 to that in 1991?
Give a very brief answer. 0.06. What is the ratio of the Aid flow (current US$) of Honduras in 1990 to that in 1991?
Provide a short and direct response. 1.94. What is the ratio of the Aid flow (current US$) of Paraguay in 1990 to that in 1991?
Ensure brevity in your answer.  0.01. What is the ratio of the Aid flow (current US$) of Turkey in 1990 to that in 1991?
Offer a terse response. 1.08. What is the difference between the highest and the second highest Aid flow (current US$) of Equatorial Guinea?
Your answer should be compact. 1.32e+06. What is the difference between the highest and the second highest Aid flow (current US$) in Honduras?
Provide a short and direct response. 1.28e+07. What is the difference between the highest and the second highest Aid flow (current US$) of Paraguay?
Ensure brevity in your answer.  5.64e+07. What is the difference between the highest and the lowest Aid flow (current US$) of Equatorial Guinea?
Make the answer very short. 3.56e+06. What is the difference between the highest and the lowest Aid flow (current US$) of Honduras?
Ensure brevity in your answer.  2.57e+07. What is the difference between the highest and the lowest Aid flow (current US$) of Paraguay?
Ensure brevity in your answer.  5.69e+07. What is the difference between the highest and the lowest Aid flow (current US$) of Turkey?
Provide a succinct answer. 2.22e+07. 